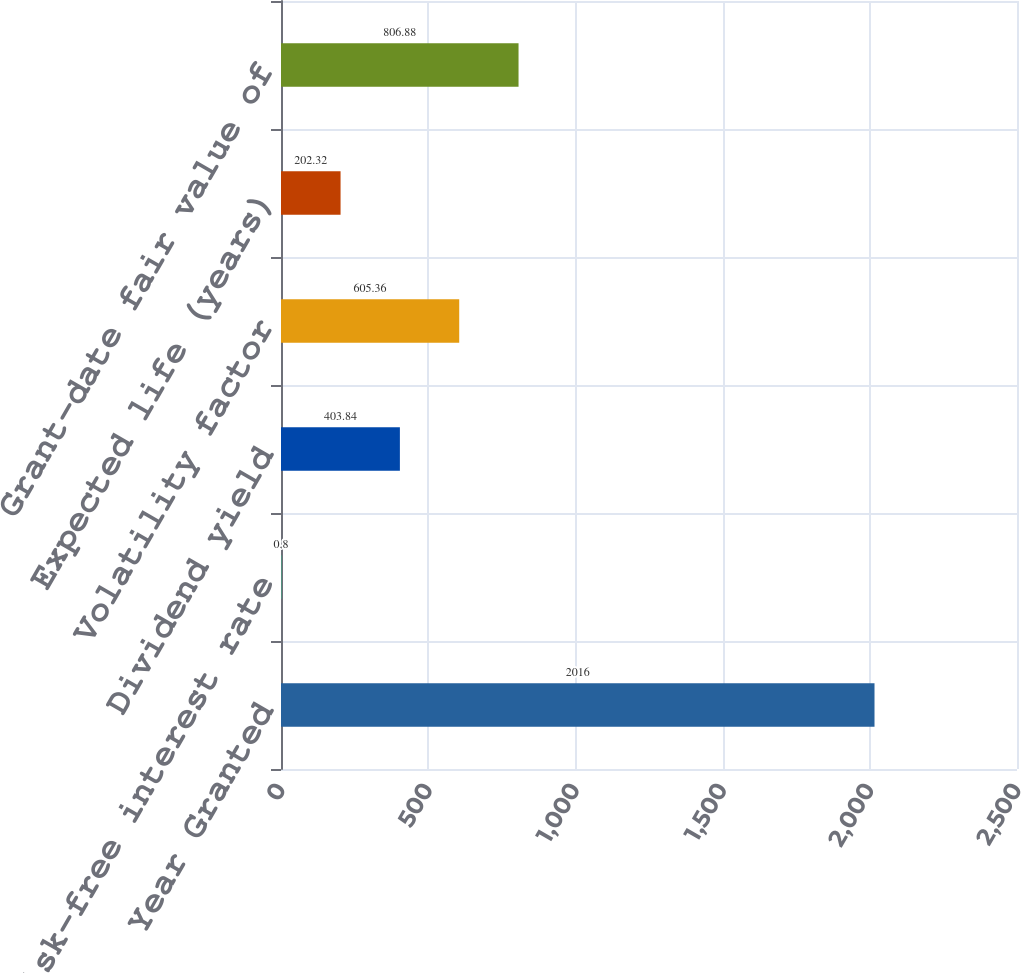Convert chart to OTSL. <chart><loc_0><loc_0><loc_500><loc_500><bar_chart><fcel>Year Granted<fcel>Risk-free interest rate<fcel>Dividend yield<fcel>Volatility factor<fcel>Expected life (years)<fcel>Grant-date fair value of<nl><fcel>2016<fcel>0.8<fcel>403.84<fcel>605.36<fcel>202.32<fcel>806.88<nl></chart> 